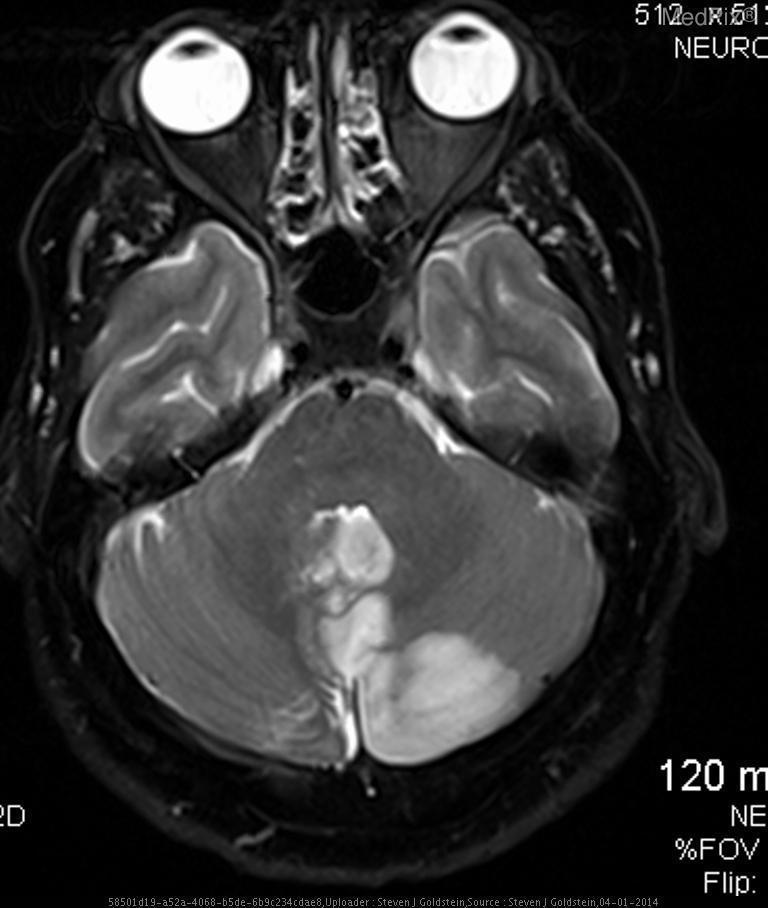What does the abnormality in this image represent?
Give a very brief answer. Infarct. Where is the infarct?
Quick response, please. Left cerebellum. Which vessel is infarcted in this image?
Keep it brief. Right pica. What area of cerebrum is visible?
Keep it brief. Temporal lobe. Which lobe of the cerebrum is visible?
Short answer required. Temporal lobe. Is there a skull fracture present?
Concise answer only. No. Is the skull fractured?
Write a very short answer. No. 